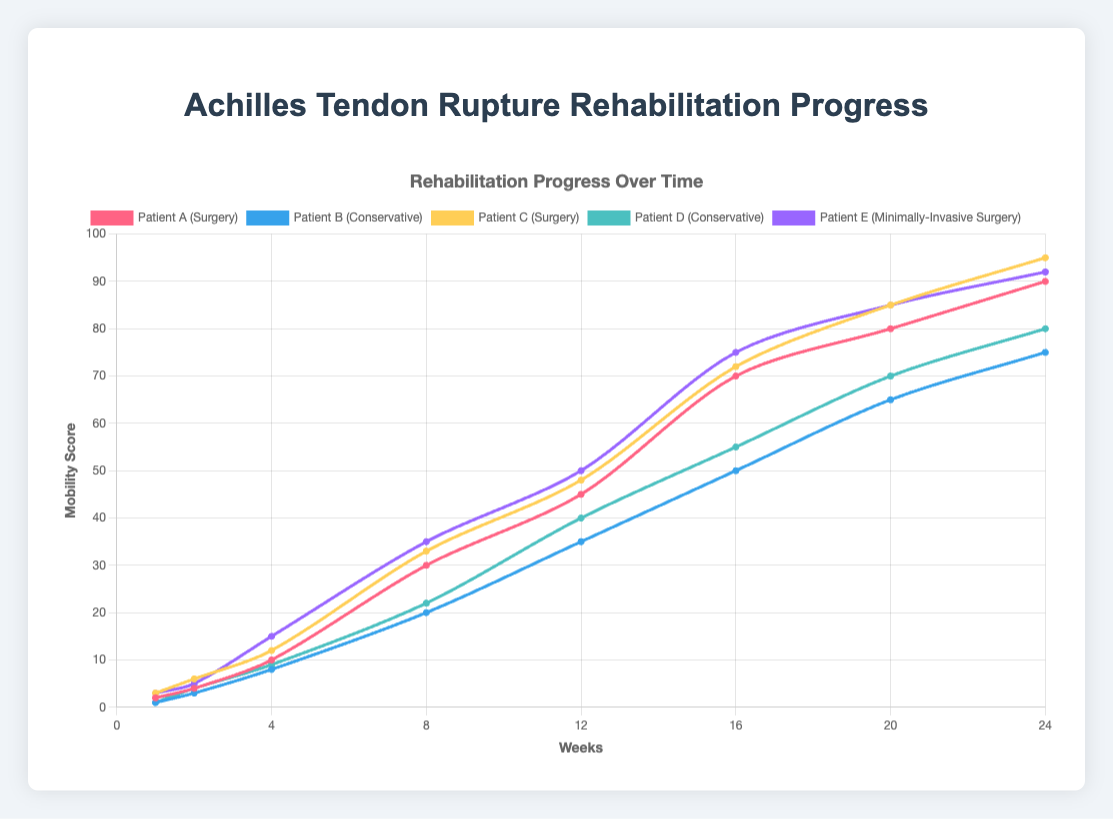What treatment method has the highest mobility score by week 24? By week 24, Patient C (Surgery) has the highest mobility score. Looking at the figure, we see that Patient C's mobility score reaches 95.
Answer: Surgery Which patient shows the fastest improvement in mobility scores between weeks 1 and 4? Comparing mobility scores between weeks 1 and 4 for all patients, Patient E's score increases from 3 to 15, an increase of 12 points. Patient E (Minimally-Invasive Surgery) shows the fastest improvement during weeks 1 to 4.
Answer: Patient E How does the rehabilitation progress differ between surgery and conservative treatment after 8 weeks? By week 8, surgery patients (Patient A and Patient C) have mobility scores of 30 and 33 respectively, whereas conservative treatment patients (Patient B and Patient D) have scores of 20 and 22 respectively. Surgery tends to result in higher mobility scores than conservative treatment after 8 weeks.
Answer: Surgery shows better progress When does Patient A reach a mobility score of 45? Patient A reaches a mobility score of 45 at week 12. This is seen from the figure where at week 12, the line for Patient A intersects the 45 mobility score mark.
Answer: Week 12 Between weeks 4 and 16, which patient treated with surgery shows the steepest increase in mobility score? For patients treated with surgery, Patient C shows a steeper increase from week 4 with a mobility score of 12 up to week 16 with a score of 72, a total increase of 60 points, compared to Patient A's increase from 10 to 70, which is 60 points. However, Patient C's slope is steeper due to the higher starting and ending points.
Answer: Patient C What is the average mobility score of patients treated conservatively at week 16? Patient B has a score of 50, and Patient D has a score of 55 at week 16. The average is calculated as (50 + 55)/2 = 52.5.
Answer: 52.5 Which patient has a lower mobility score at week 24, Patient B or Patient D, and by how much? Patient B has a mobility score of 75 and Patient D has a score of 80 at week 24. Patient D has a higher score, so Patient B's score is lower by 80 - 75 = 5 points.
Answer: Patient B by 5 points At what week does Patient E show the same mobility score as Patient A? Patient E shows the same mobility score as Patient A at week 16, where both have a mobility score of 70.
Answer: Week 16 Which treatment method generally results in higher mobility scores by week 24, conservative or minimally-invasive surgery? At week 24, the mobility scores for minimally-invasive surgery (Patient E) is 92, compared to conservative treatment (Patients B and D) which are 75 and 80 respectively. Minimally-invasive surgery generally results in higher mobility scores.
Answer: Minimally-Invasive Surgery 